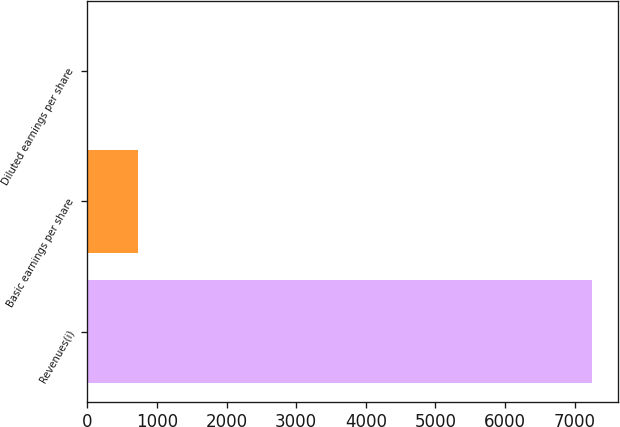Convert chart to OTSL. <chart><loc_0><loc_0><loc_500><loc_500><bar_chart><fcel>Revenues(i)<fcel>Basic earnings per share<fcel>Diluted earnings per share<nl><fcel>7258<fcel>725.9<fcel>0.11<nl></chart> 